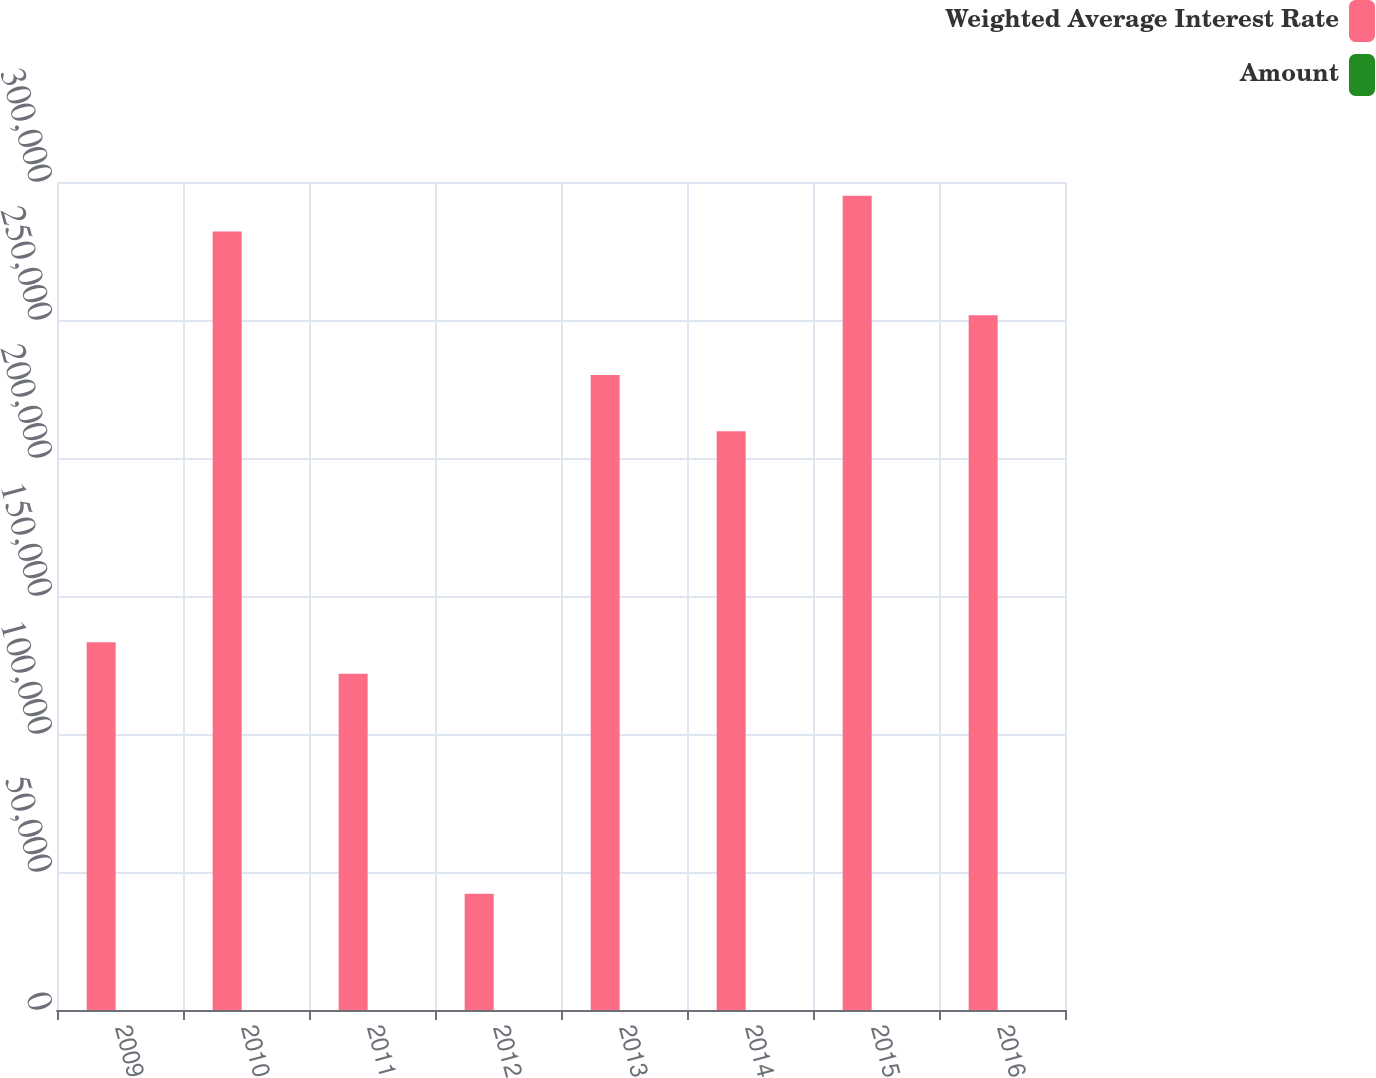<chart> <loc_0><loc_0><loc_500><loc_500><stacked_bar_chart><ecel><fcel>2009<fcel>2010<fcel>2011<fcel>2012<fcel>2013<fcel>2014<fcel>2015<fcel>2016<nl><fcel>Weighted Average Interest Rate<fcel>133217<fcel>282028<fcel>121813<fcel>42076<fcel>230029<fcel>209684<fcel>294975<fcel>251751<nl><fcel>Amount<fcel>6.12<fcel>5.24<fcel>5.44<fcel>5.81<fcel>6.05<fcel>5.89<fcel>5.71<fcel>6.52<nl></chart> 